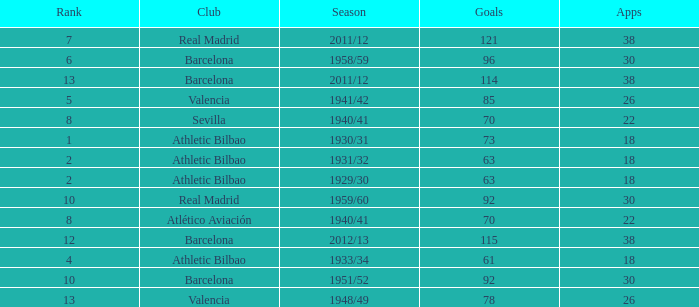What are the apps for less than 61 goals and before rank 6? None. Write the full table. {'header': ['Rank', 'Club', 'Season', 'Goals', 'Apps'], 'rows': [['7', 'Real Madrid', '2011/12', '121', '38'], ['6', 'Barcelona', '1958/59', '96', '30'], ['13', 'Barcelona', '2011/12', '114', '38'], ['5', 'Valencia', '1941/42', '85', '26'], ['8', 'Sevilla', '1940/41', '70', '22'], ['1', 'Athletic Bilbao', '1930/31', '73', '18'], ['2', 'Athletic Bilbao', '1931/32', '63', '18'], ['2', 'Athletic Bilbao', '1929/30', '63', '18'], ['10', 'Real Madrid', '1959/60', '92', '30'], ['8', 'Atlético Aviación', '1940/41', '70', '22'], ['12', 'Barcelona', '2012/13', '115', '38'], ['4', 'Athletic Bilbao', '1933/34', '61', '18'], ['10', 'Barcelona', '1951/52', '92', '30'], ['13', 'Valencia', '1948/49', '78', '26']]} 